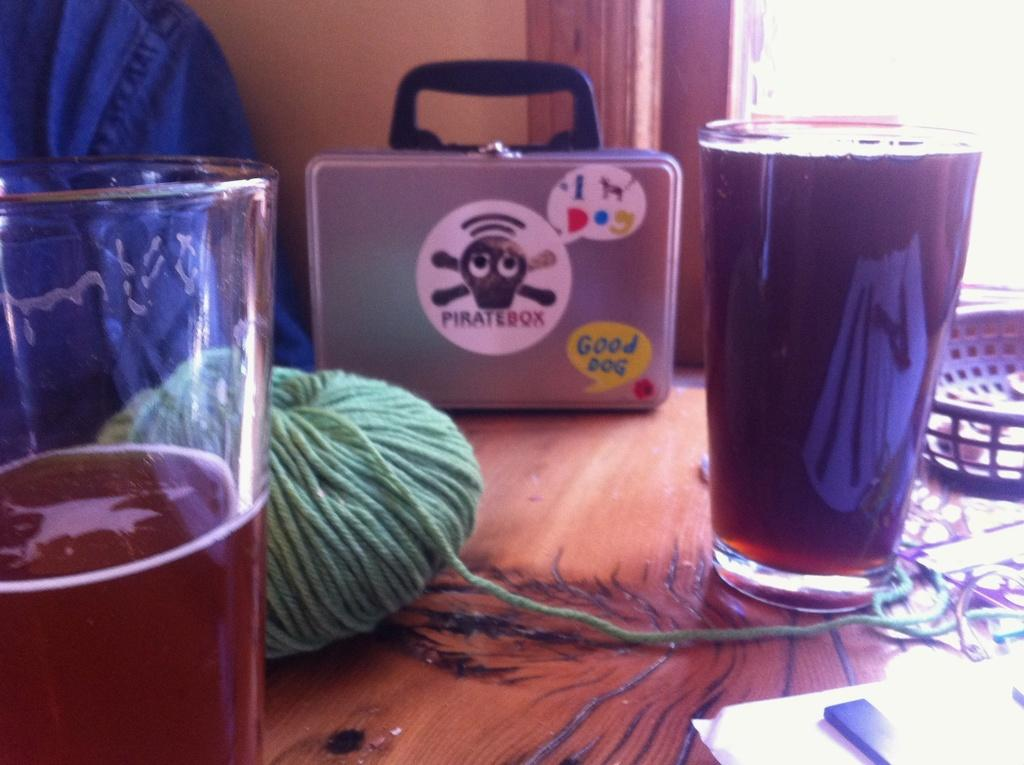Provide a one-sentence caption for the provided image. An assortment of items is on a wood table, including a metallic looking lunch box or briefcase that says "Piratebox" on it. 